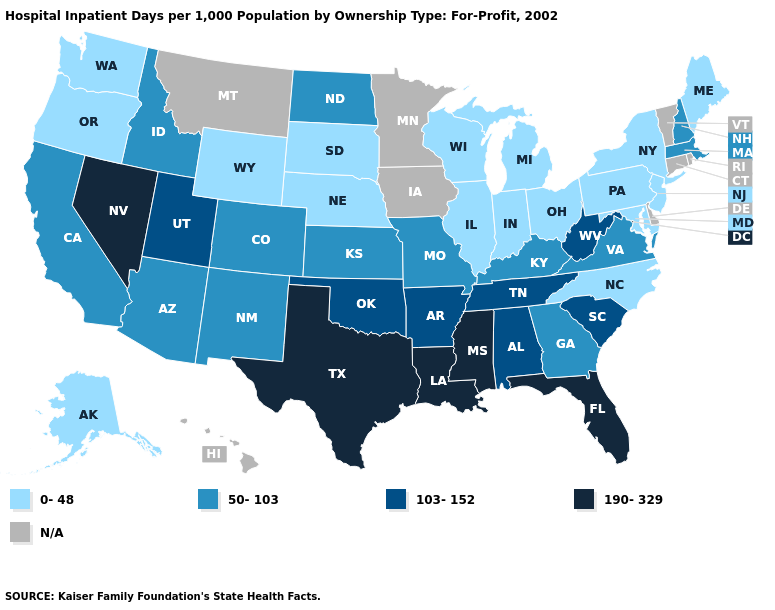What is the highest value in the USA?
Give a very brief answer. 190-329. Name the states that have a value in the range 0-48?
Concise answer only. Alaska, Illinois, Indiana, Maine, Maryland, Michigan, Nebraska, New Jersey, New York, North Carolina, Ohio, Oregon, Pennsylvania, South Dakota, Washington, Wisconsin, Wyoming. Which states have the highest value in the USA?
Give a very brief answer. Florida, Louisiana, Mississippi, Nevada, Texas. What is the lowest value in the South?
Concise answer only. 0-48. What is the lowest value in the West?
Keep it brief. 0-48. What is the value of Tennessee?
Quick response, please. 103-152. What is the value of Nevada?
Give a very brief answer. 190-329. Among the states that border Wyoming , which have the lowest value?
Be succinct. Nebraska, South Dakota. Is the legend a continuous bar?
Answer briefly. No. What is the value of Wyoming?
Be succinct. 0-48. Name the states that have a value in the range 50-103?
Quick response, please. Arizona, California, Colorado, Georgia, Idaho, Kansas, Kentucky, Massachusetts, Missouri, New Hampshire, New Mexico, North Dakota, Virginia. Which states have the highest value in the USA?
Concise answer only. Florida, Louisiana, Mississippi, Nevada, Texas. Name the states that have a value in the range 0-48?
Concise answer only. Alaska, Illinois, Indiana, Maine, Maryland, Michigan, Nebraska, New Jersey, New York, North Carolina, Ohio, Oregon, Pennsylvania, South Dakota, Washington, Wisconsin, Wyoming. What is the value of Washington?
Keep it brief. 0-48. What is the value of Iowa?
Quick response, please. N/A. 